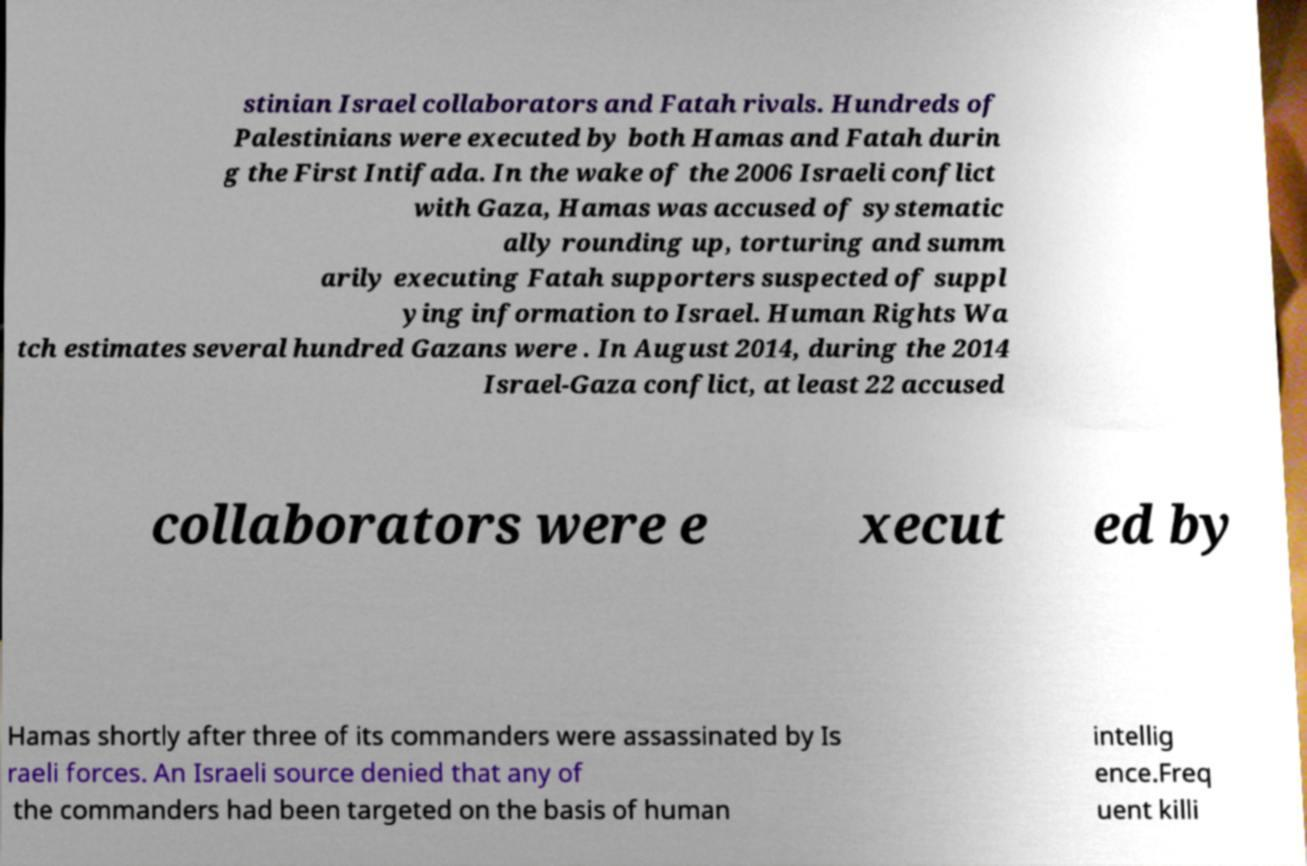For documentation purposes, I need the text within this image transcribed. Could you provide that? stinian Israel collaborators and Fatah rivals. Hundreds of Palestinians were executed by both Hamas and Fatah durin g the First Intifada. In the wake of the 2006 Israeli conflict with Gaza, Hamas was accused of systematic ally rounding up, torturing and summ arily executing Fatah supporters suspected of suppl ying information to Israel. Human Rights Wa tch estimates several hundred Gazans were . In August 2014, during the 2014 Israel-Gaza conflict, at least 22 accused collaborators were e xecut ed by Hamas shortly after three of its commanders were assassinated by Is raeli forces. An Israeli source denied that any of the commanders had been targeted on the basis of human intellig ence.Freq uent killi 